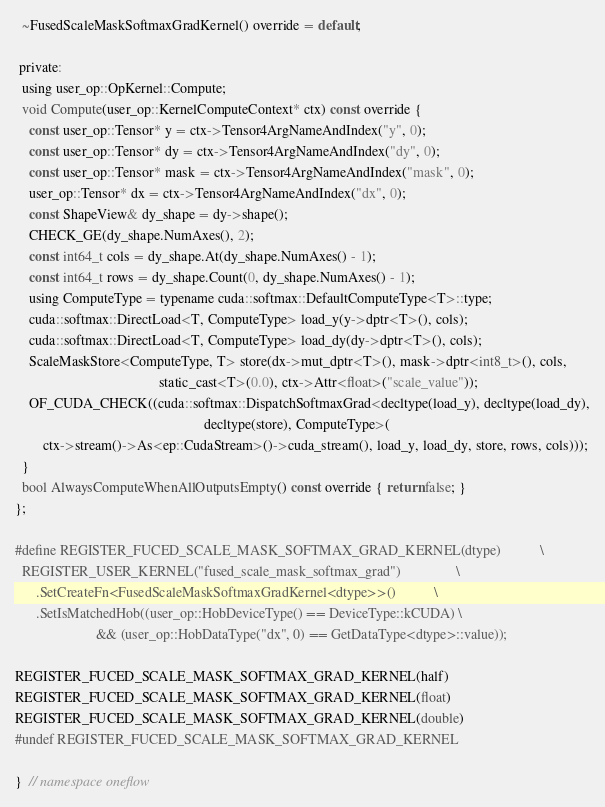Convert code to text. <code><loc_0><loc_0><loc_500><loc_500><_Cuda_>  ~FusedScaleMaskSoftmaxGradKernel() override = default;

 private:
  using user_op::OpKernel::Compute;
  void Compute(user_op::KernelComputeContext* ctx) const override {
    const user_op::Tensor* y = ctx->Tensor4ArgNameAndIndex("y", 0);
    const user_op::Tensor* dy = ctx->Tensor4ArgNameAndIndex("dy", 0);
    const user_op::Tensor* mask = ctx->Tensor4ArgNameAndIndex("mask", 0);
    user_op::Tensor* dx = ctx->Tensor4ArgNameAndIndex("dx", 0);
    const ShapeView& dy_shape = dy->shape();
    CHECK_GE(dy_shape.NumAxes(), 2);
    const int64_t cols = dy_shape.At(dy_shape.NumAxes() - 1);
    const int64_t rows = dy_shape.Count(0, dy_shape.NumAxes() - 1);
    using ComputeType = typename cuda::softmax::DefaultComputeType<T>::type;
    cuda::softmax::DirectLoad<T, ComputeType> load_y(y->dptr<T>(), cols);
    cuda::softmax::DirectLoad<T, ComputeType> load_dy(dy->dptr<T>(), cols);
    ScaleMaskStore<ComputeType, T> store(dx->mut_dptr<T>(), mask->dptr<int8_t>(), cols,
                                         static_cast<T>(0.0), ctx->Attr<float>("scale_value"));
    OF_CUDA_CHECK((cuda::softmax::DispatchSoftmaxGrad<decltype(load_y), decltype(load_dy),
                                                      decltype(store), ComputeType>(
        ctx->stream()->As<ep::CudaStream>()->cuda_stream(), load_y, load_dy, store, rows, cols)));
  }
  bool AlwaysComputeWhenAllOutputsEmpty() const override { return false; }
};

#define REGISTER_FUCED_SCALE_MASK_SOFTMAX_GRAD_KERNEL(dtype)           \
  REGISTER_USER_KERNEL("fused_scale_mask_softmax_grad")                \
      .SetCreateFn<FusedScaleMaskSoftmaxGradKernel<dtype>>()           \
      .SetIsMatchedHob((user_op::HobDeviceType() == DeviceType::kCUDA) \
                       && (user_op::HobDataType("dx", 0) == GetDataType<dtype>::value));

REGISTER_FUCED_SCALE_MASK_SOFTMAX_GRAD_KERNEL(half)
REGISTER_FUCED_SCALE_MASK_SOFTMAX_GRAD_KERNEL(float)
REGISTER_FUCED_SCALE_MASK_SOFTMAX_GRAD_KERNEL(double)
#undef REGISTER_FUCED_SCALE_MASK_SOFTMAX_GRAD_KERNEL

}  // namespace oneflow
</code> 